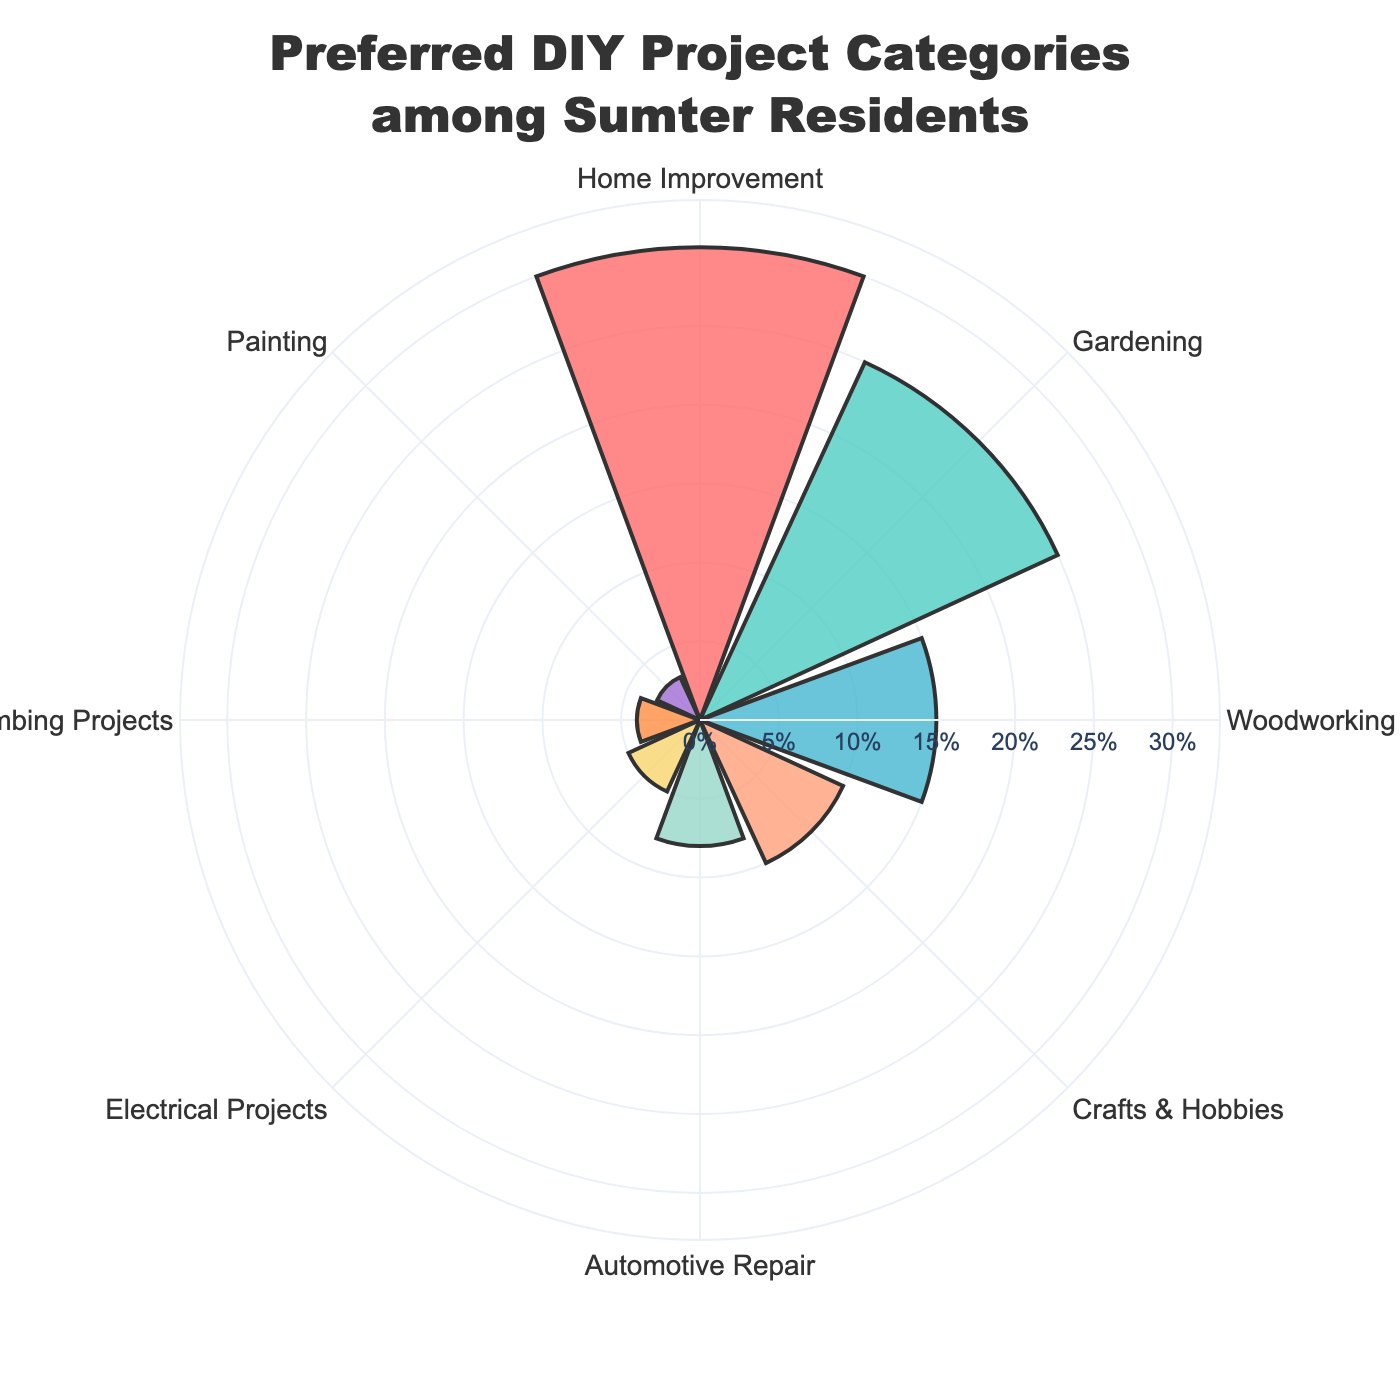what is the title of the chart? The title of the chart is displayed prominently at the top of the figure.
Answer: Preferred DIY Project Categories among Sumter Residents What is the smallest category represented? The smallest category is the one with the shortest bar and the smallest percentage value.
Answer: Painting How many categories have a percentage of 10% or higher? We need to count all the categories that have a percentage value equal to or greater than 10%.
Answer: 4 What is the percentage difference between Home Improvement and Gardening? Subtract the percentage of Gardening from the percentage of Home Improvement. 30% - 25% = 5%.
Answer: 5% Which category has a higher percentage: Electrical Projects or Plumbing Projects? Compare the percentage values of Electrical Projects and Plumbing Projects. Electrical Projects has 5% while Plumbing Projects has 4%.
Answer: Electrical Projects How many categories have a percentage of less than 10%? Count the categories with a percentage value less than 10%.
Answer: 4 What is the combined percentage of Craft & Hobbies and Automotive Repair? Add the percentages of Craft & Hobbies (10%) and Automotive Repair (8%) together. 10% + 8% = 18%.
Answer: 18% Is the percentage of Woodworking greater than or less than half of Gardening? Calculate half of Gardening's percentage (25% / 2 = 12.5%) and compare it to Woodworking's percentage (15%).
Answer: Greater What color is used for the category with the highest percentage? Identify the color corresponding to the largest bar in the chart.
Answer: Red How is the data sorted in the chart? Observe the order of categories; they are arranged based on the percentage from highest to lowest.
Answer: By percentage in descending order 